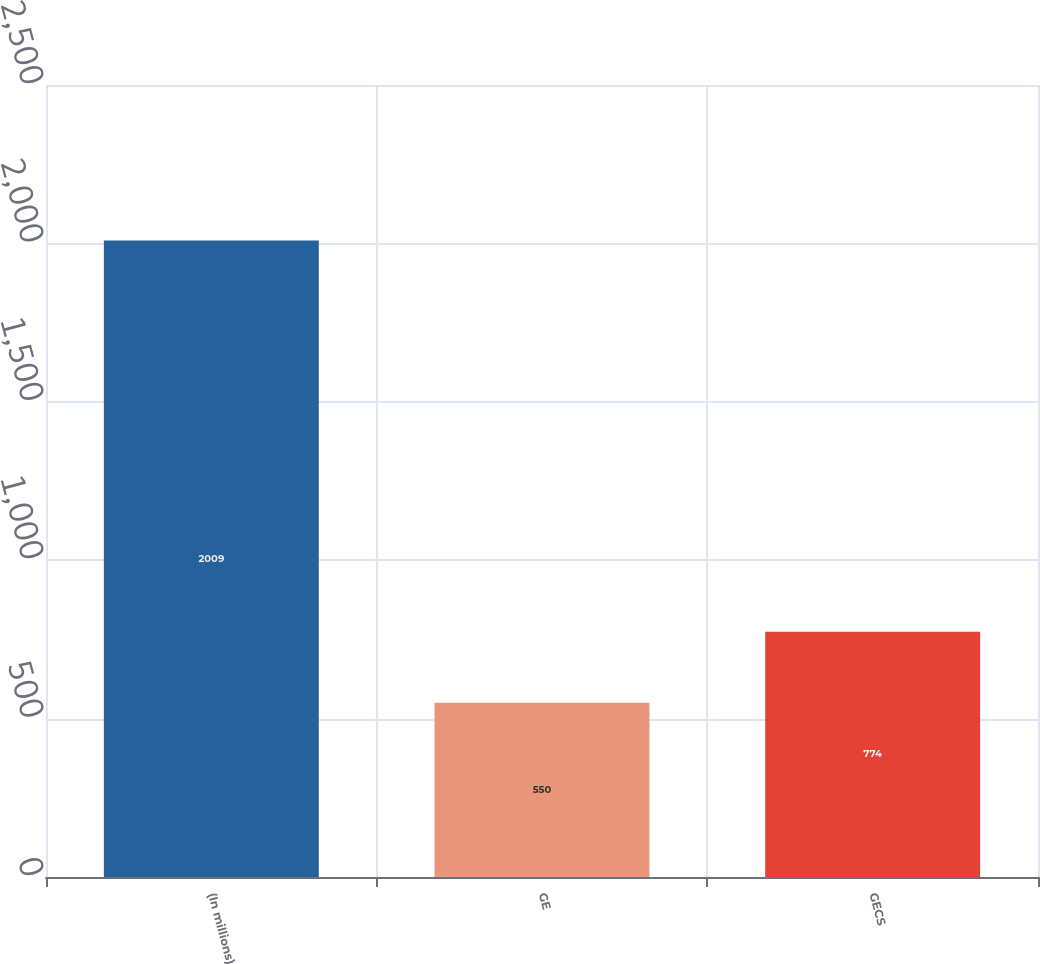<chart> <loc_0><loc_0><loc_500><loc_500><bar_chart><fcel>(In millions)<fcel>GE<fcel>GECS<nl><fcel>2009<fcel>550<fcel>774<nl></chart> 